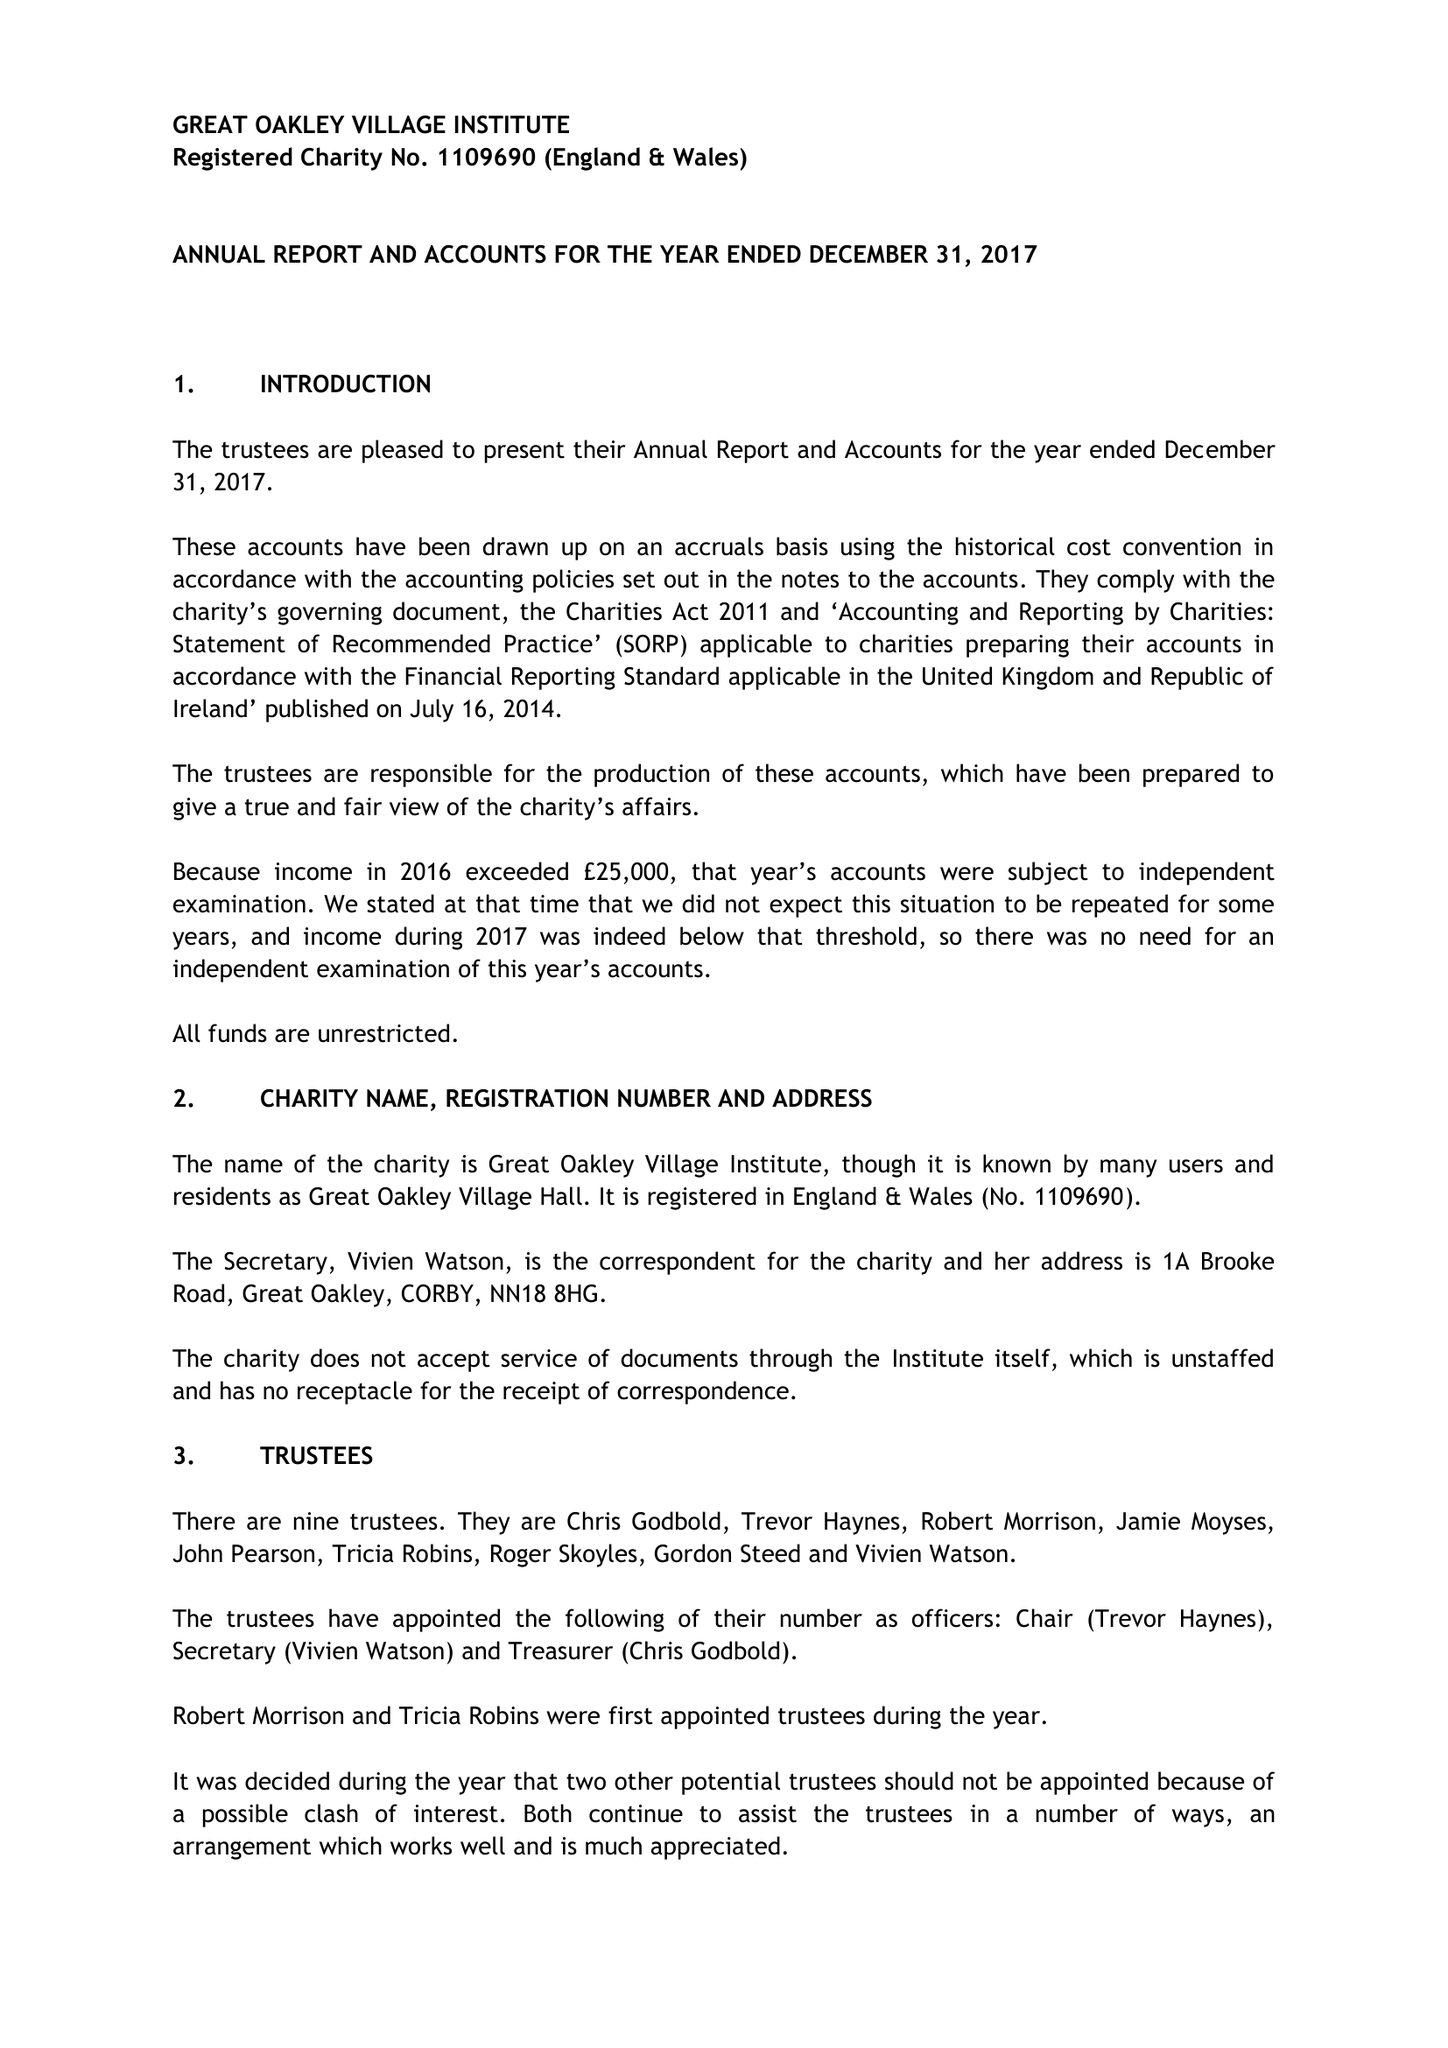What is the value for the income_annually_in_british_pounds?
Answer the question using a single word or phrase. 25365.76 